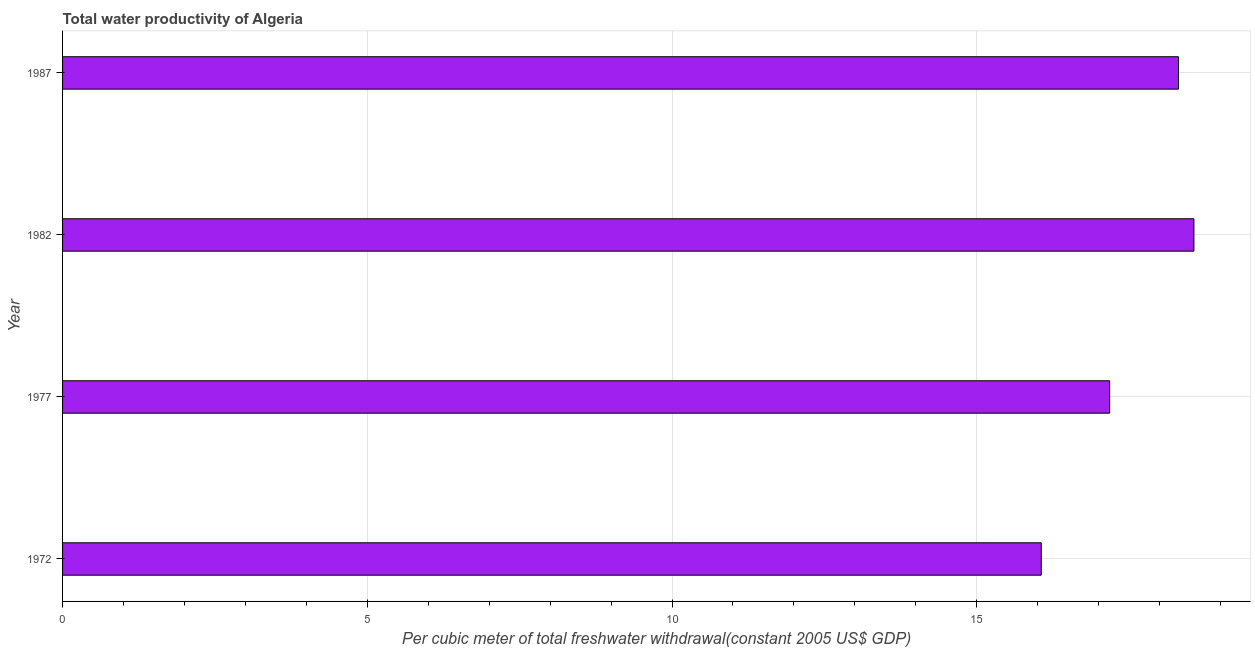What is the title of the graph?
Your answer should be very brief. Total water productivity of Algeria. What is the label or title of the X-axis?
Offer a very short reply. Per cubic meter of total freshwater withdrawal(constant 2005 US$ GDP). What is the label or title of the Y-axis?
Ensure brevity in your answer.  Year. What is the total water productivity in 1982?
Offer a very short reply. 18.56. Across all years, what is the maximum total water productivity?
Provide a short and direct response. 18.56. Across all years, what is the minimum total water productivity?
Your response must be concise. 16.06. In which year was the total water productivity maximum?
Your response must be concise. 1982. What is the sum of the total water productivity?
Your response must be concise. 70.11. What is the difference between the total water productivity in 1972 and 1982?
Offer a terse response. -2.5. What is the average total water productivity per year?
Give a very brief answer. 17.53. What is the median total water productivity?
Your response must be concise. 17.75. Do a majority of the years between 1977 and 1987 (inclusive) have total water productivity greater than 16 US$?
Give a very brief answer. Yes. What is the ratio of the total water productivity in 1977 to that in 1987?
Provide a succinct answer. 0.94. What is the difference between the highest and the second highest total water productivity?
Keep it short and to the point. 0.25. Is the sum of the total water productivity in 1972 and 1982 greater than the maximum total water productivity across all years?
Provide a short and direct response. Yes. What is the difference between the highest and the lowest total water productivity?
Your answer should be very brief. 2.51. In how many years, is the total water productivity greater than the average total water productivity taken over all years?
Offer a terse response. 2. Are all the bars in the graph horizontal?
Ensure brevity in your answer.  Yes. How many years are there in the graph?
Provide a succinct answer. 4. What is the difference between two consecutive major ticks on the X-axis?
Your answer should be very brief. 5. What is the Per cubic meter of total freshwater withdrawal(constant 2005 US$ GDP) of 1972?
Provide a succinct answer. 16.06. What is the Per cubic meter of total freshwater withdrawal(constant 2005 US$ GDP) of 1977?
Offer a terse response. 17.18. What is the Per cubic meter of total freshwater withdrawal(constant 2005 US$ GDP) in 1982?
Your answer should be compact. 18.56. What is the Per cubic meter of total freshwater withdrawal(constant 2005 US$ GDP) of 1987?
Give a very brief answer. 18.31. What is the difference between the Per cubic meter of total freshwater withdrawal(constant 2005 US$ GDP) in 1972 and 1977?
Your answer should be compact. -1.12. What is the difference between the Per cubic meter of total freshwater withdrawal(constant 2005 US$ GDP) in 1972 and 1982?
Make the answer very short. -2.51. What is the difference between the Per cubic meter of total freshwater withdrawal(constant 2005 US$ GDP) in 1972 and 1987?
Your response must be concise. -2.25. What is the difference between the Per cubic meter of total freshwater withdrawal(constant 2005 US$ GDP) in 1977 and 1982?
Provide a succinct answer. -1.38. What is the difference between the Per cubic meter of total freshwater withdrawal(constant 2005 US$ GDP) in 1977 and 1987?
Ensure brevity in your answer.  -1.13. What is the difference between the Per cubic meter of total freshwater withdrawal(constant 2005 US$ GDP) in 1982 and 1987?
Make the answer very short. 0.25. What is the ratio of the Per cubic meter of total freshwater withdrawal(constant 2005 US$ GDP) in 1972 to that in 1977?
Your answer should be compact. 0.94. What is the ratio of the Per cubic meter of total freshwater withdrawal(constant 2005 US$ GDP) in 1972 to that in 1982?
Provide a short and direct response. 0.86. What is the ratio of the Per cubic meter of total freshwater withdrawal(constant 2005 US$ GDP) in 1972 to that in 1987?
Your answer should be compact. 0.88. What is the ratio of the Per cubic meter of total freshwater withdrawal(constant 2005 US$ GDP) in 1977 to that in 1982?
Keep it short and to the point. 0.93. What is the ratio of the Per cubic meter of total freshwater withdrawal(constant 2005 US$ GDP) in 1977 to that in 1987?
Give a very brief answer. 0.94. What is the ratio of the Per cubic meter of total freshwater withdrawal(constant 2005 US$ GDP) in 1982 to that in 1987?
Ensure brevity in your answer.  1.01. 